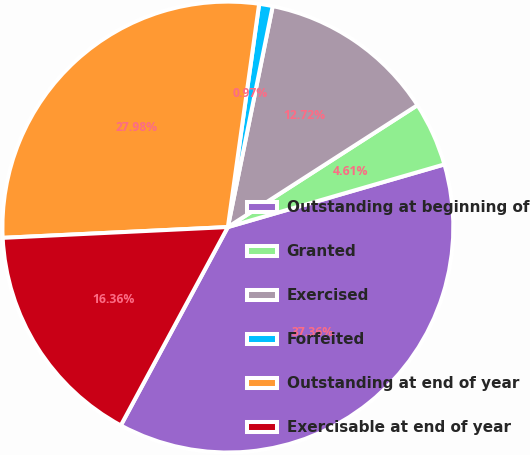Convert chart. <chart><loc_0><loc_0><loc_500><loc_500><pie_chart><fcel>Outstanding at beginning of<fcel>Granted<fcel>Exercised<fcel>Forfeited<fcel>Outstanding at end of year<fcel>Exercisable at end of year<nl><fcel>37.36%<fcel>4.61%<fcel>12.72%<fcel>0.97%<fcel>27.98%<fcel>16.36%<nl></chart> 